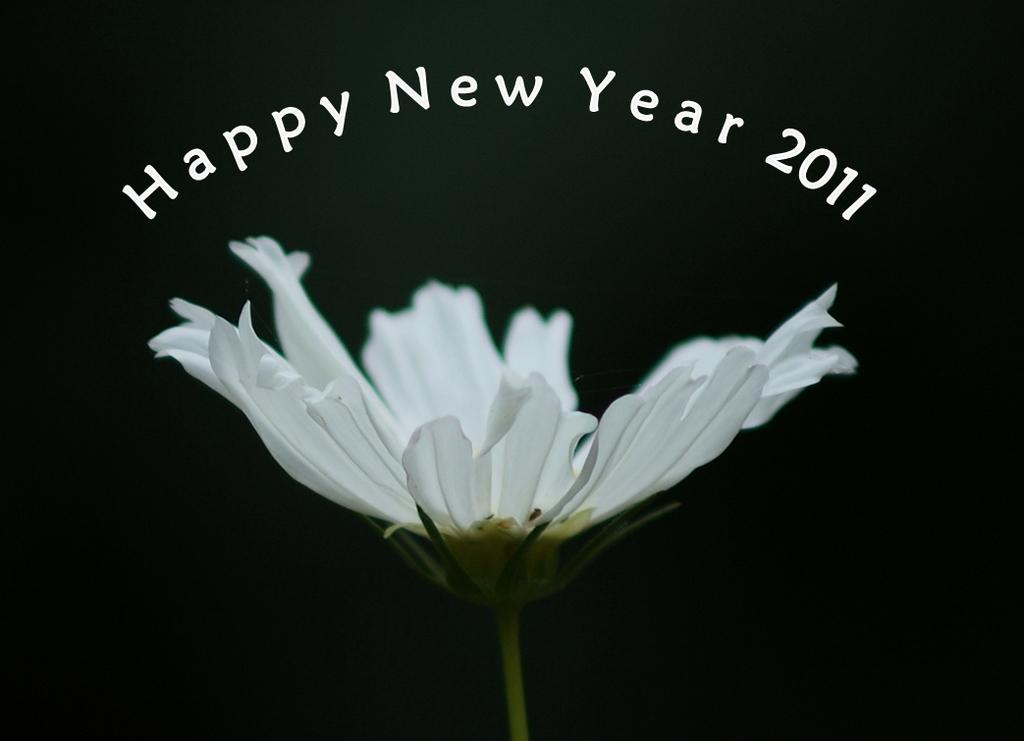What is the main subject of the image? The main subject of the image is a flower. What is the color of the flower? The color of the flower cannot be determined from the provided facts. What is the background of the image? The flower has a black background. What additional text or message is present in the image? There are new year wishes written above the flower, mentioning the year 2011. Is the flower in the image being held in a jail cell? There is no indication of a jail cell or any confinement in the image; it features a flower with a black background and new year wishes for 2011. What type of joke is being told by the flower in the image? There is no joke or any indication of humor in the image; it features a flower with a black background and new year wishes for 2011. 